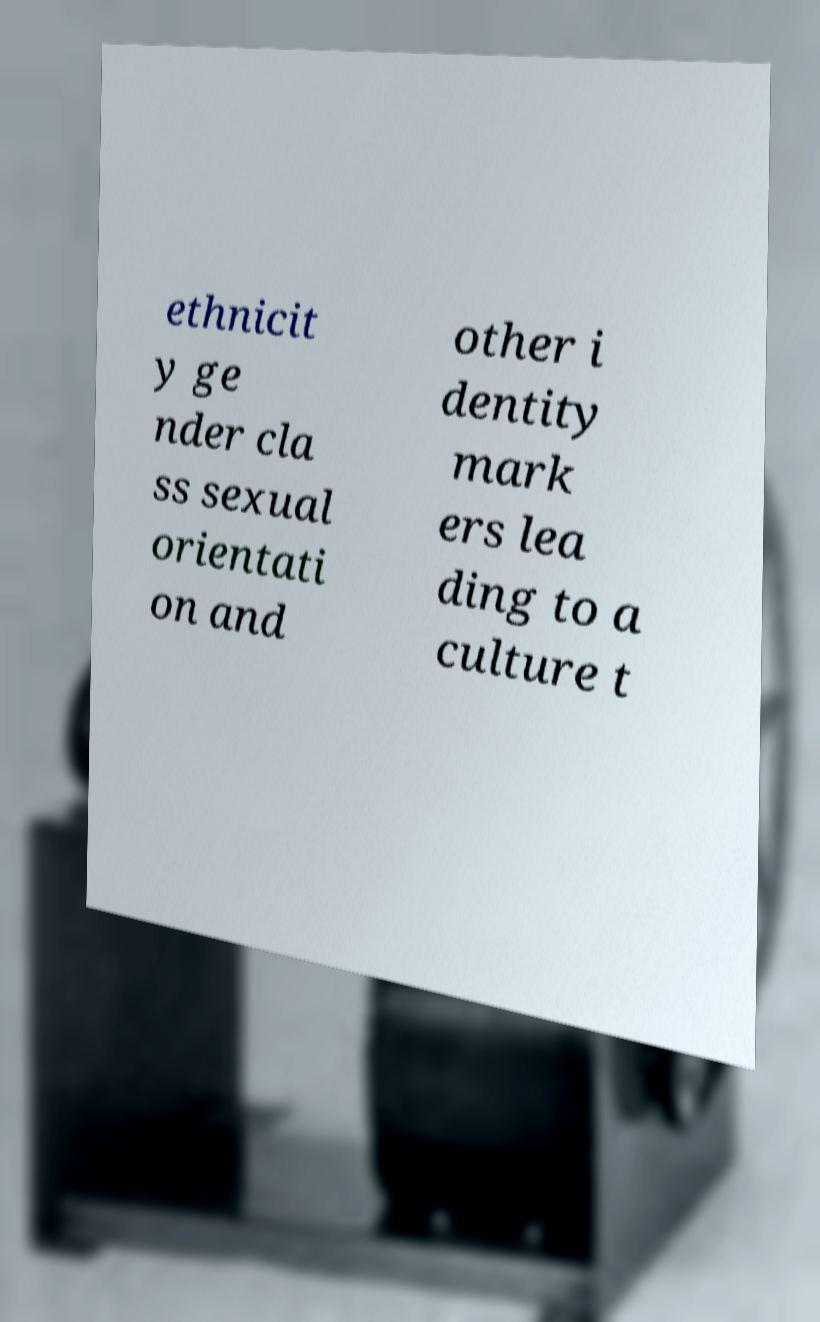Can you accurately transcribe the text from the provided image for me? ethnicit y ge nder cla ss sexual orientati on and other i dentity mark ers lea ding to a culture t 